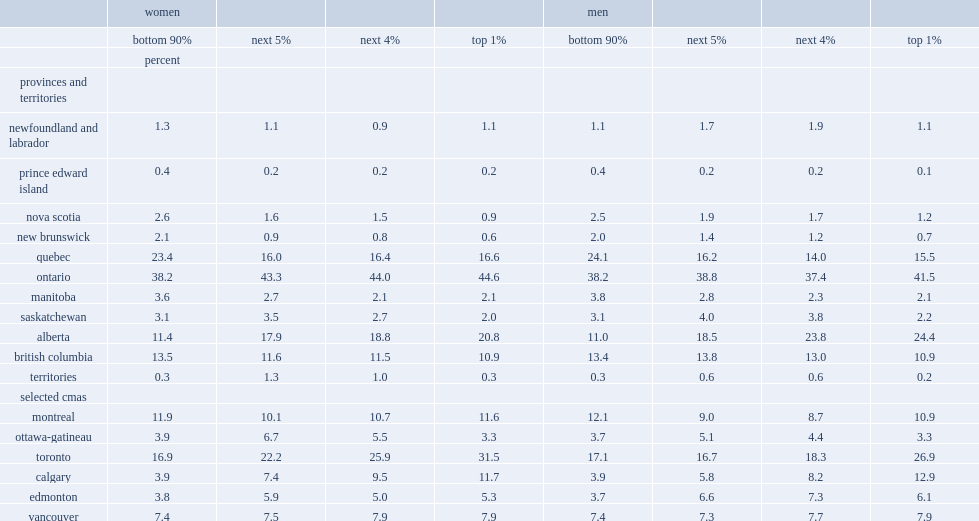What were the percentages of working women in the top 1% who lived in toronto and their male counterparts respectively? 31.5 26.9. What was the percentage of women in the bottom 90% who lived in toronto? 16.9. For workers in the top 1%,who were less likely to live in calgary or edmonton? Women. 